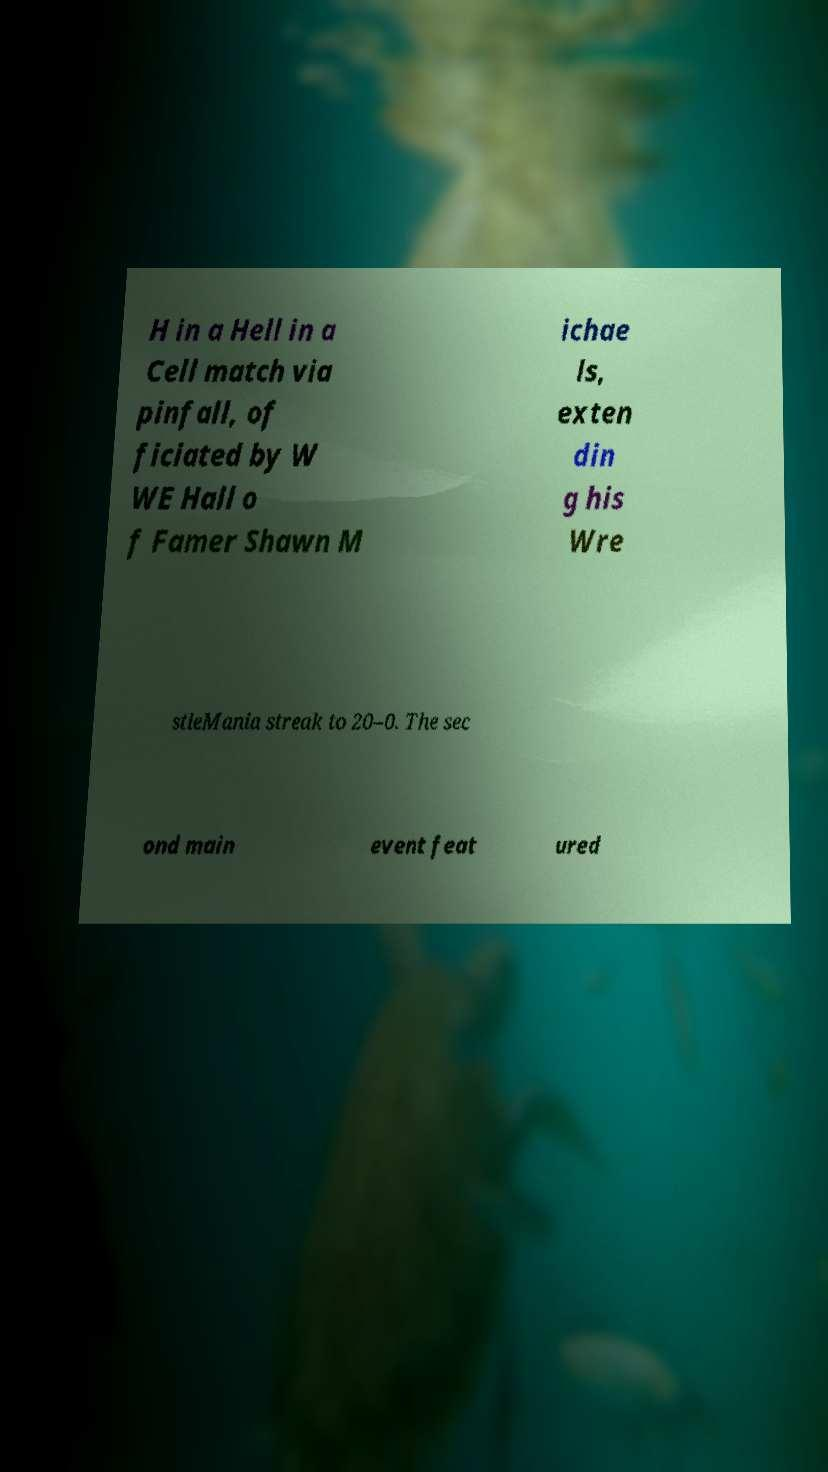Can you read and provide the text displayed in the image?This photo seems to have some interesting text. Can you extract and type it out for me? H in a Hell in a Cell match via pinfall, of ficiated by W WE Hall o f Famer Shawn M ichae ls, exten din g his Wre stleMania streak to 20–0. The sec ond main event feat ured 